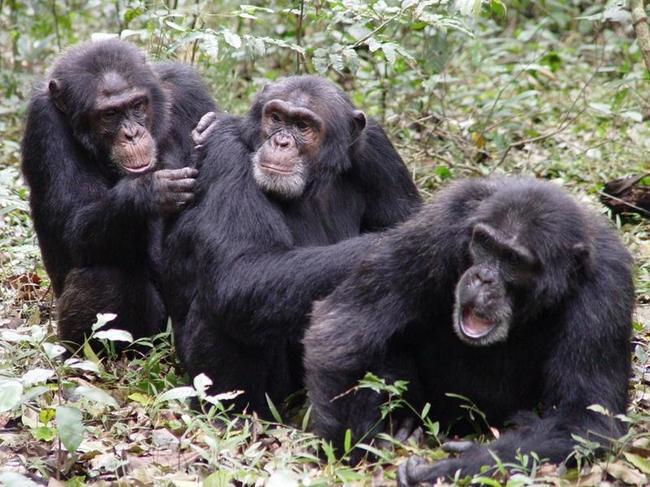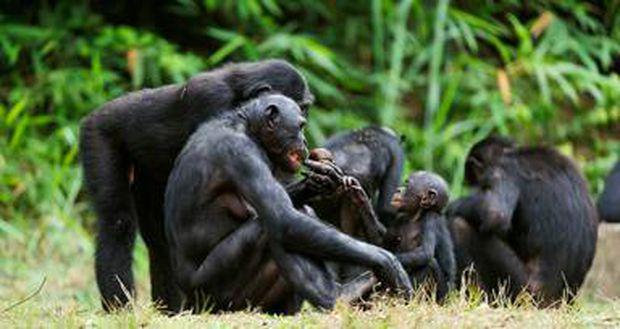The first image is the image on the left, the second image is the image on the right. Given the left and right images, does the statement "An image features one trio of interacting chimps facing forward." hold true? Answer yes or no. Yes. The first image is the image on the left, the second image is the image on the right. Considering the images on both sides, is "A baby ape is touching an adult ape's hand" valid? Answer yes or no. Yes. 